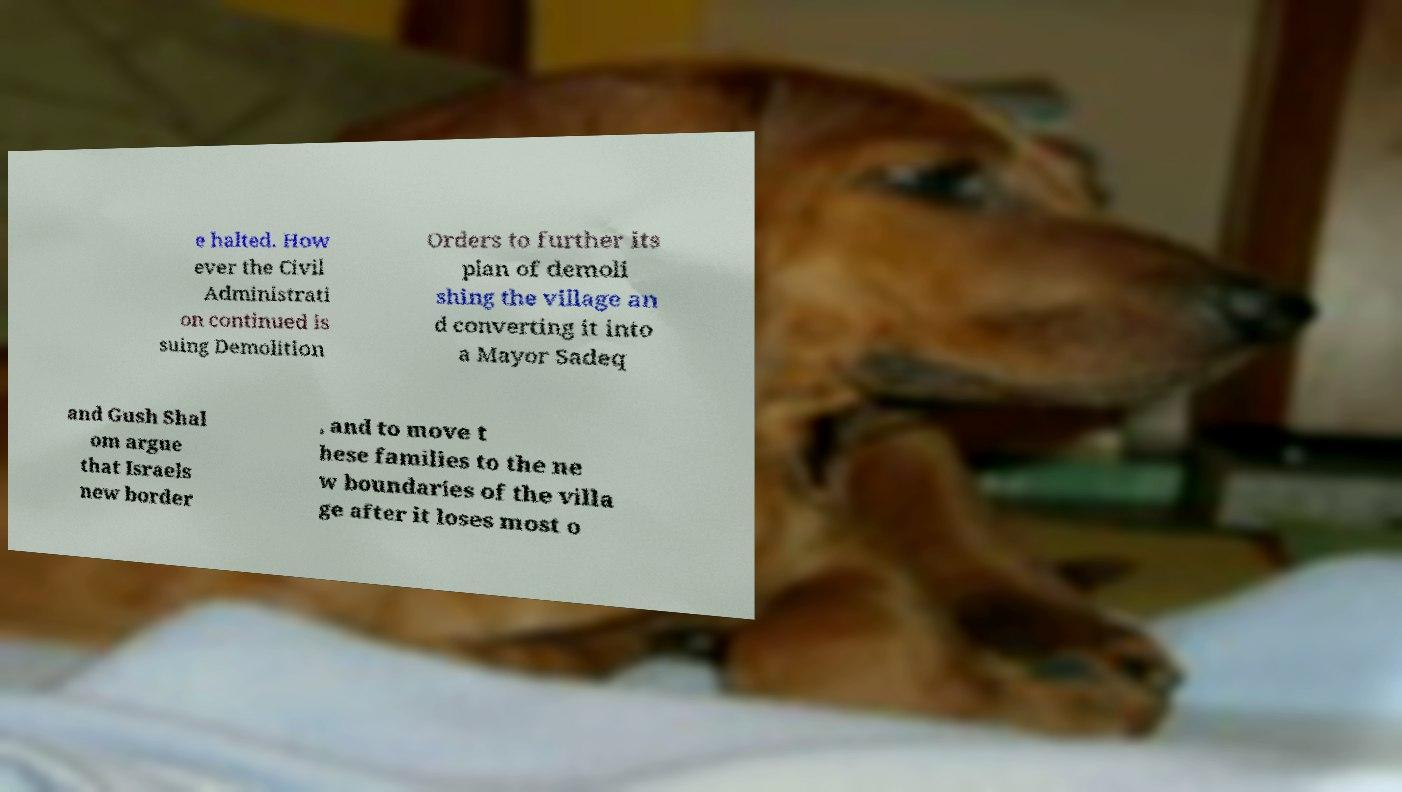Please read and relay the text visible in this image. What does it say? e halted. How ever the Civil Administrati on continued is suing Demolition Orders to further its plan of demoli shing the village an d converting it into a Mayor Sadeq and Gush Shal om argue that Israels new border , and to move t hese families to the ne w boundaries of the villa ge after it loses most o 